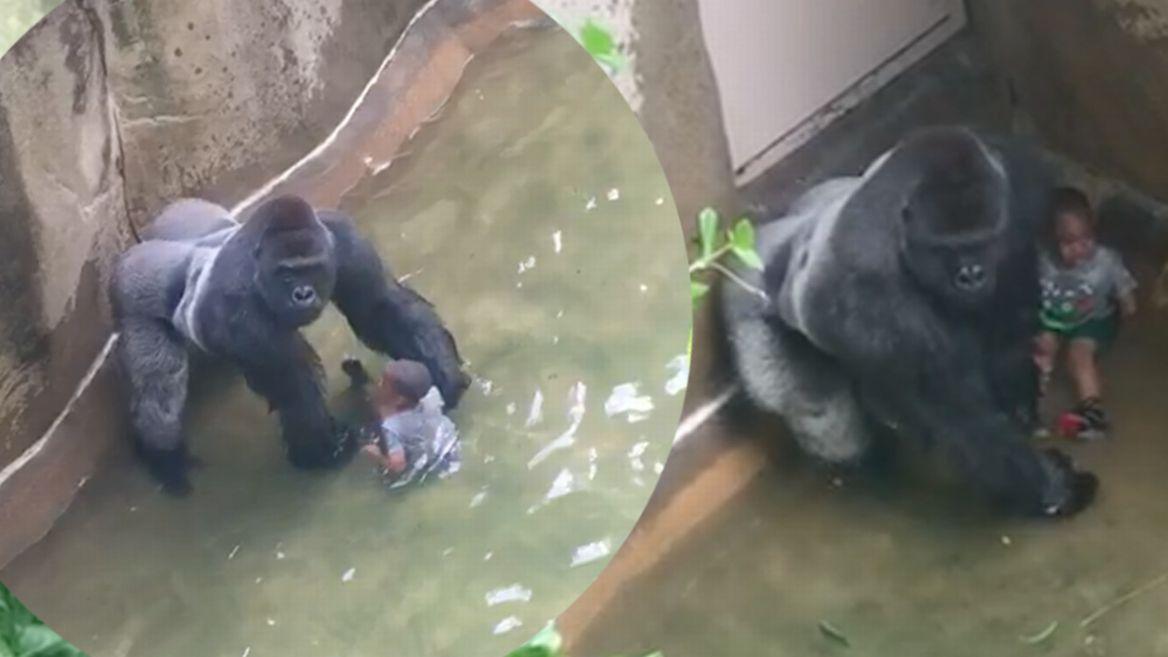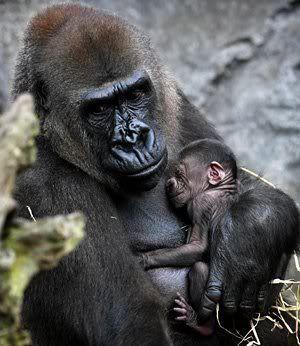The first image is the image on the left, the second image is the image on the right. Considering the images on both sides, is "One image shows a forward-gazing gorilla clutching at least one infant gorilla to its chest." valid? Answer yes or no. Yes. 